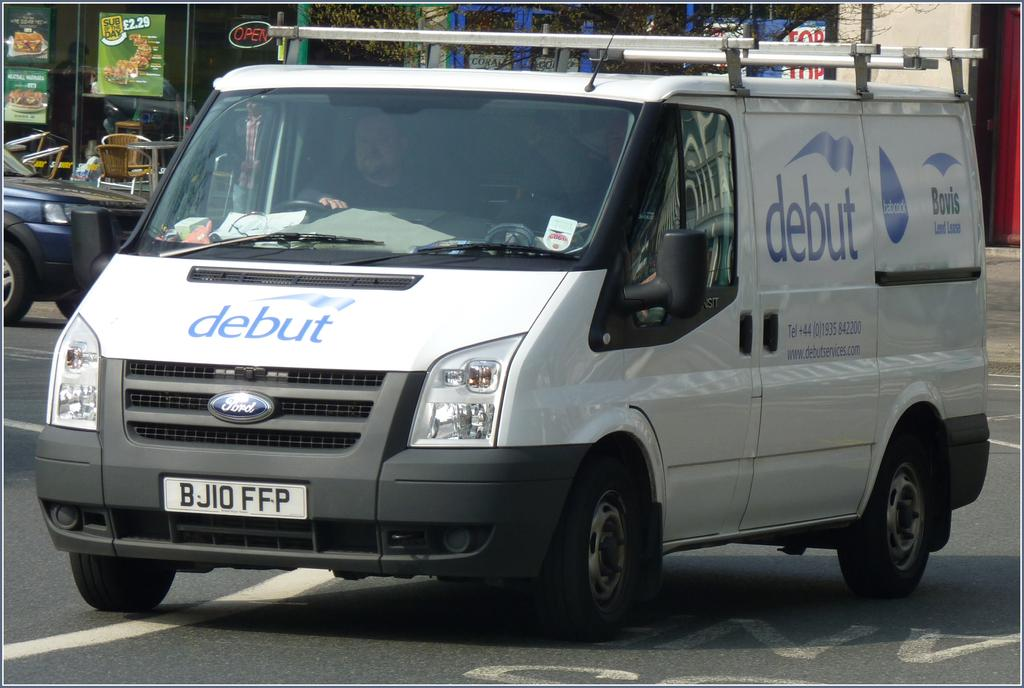<image>
Provide a brief description of the given image. a DEBUT van is driving in the middle of a street 